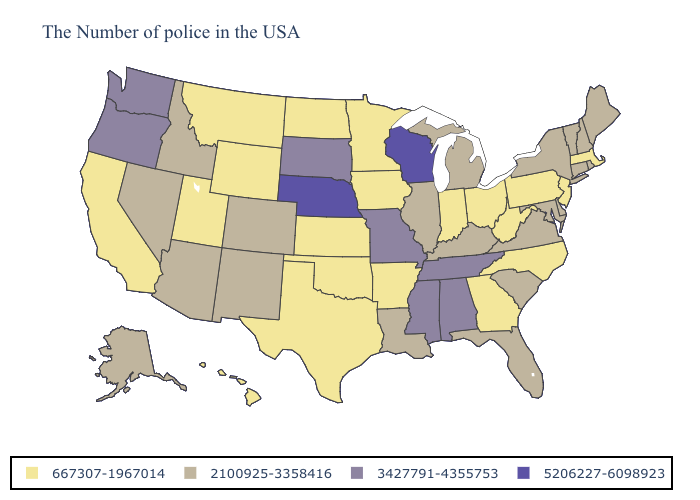Does the first symbol in the legend represent the smallest category?
Write a very short answer. Yes. Does Florida have a lower value than Alabama?
Short answer required. Yes. What is the lowest value in states that border Kentucky?
Keep it brief. 667307-1967014. What is the value of Hawaii?
Be succinct. 667307-1967014. Does Wisconsin have the same value as Nebraska?
Answer briefly. Yes. Name the states that have a value in the range 3427791-4355753?
Quick response, please. Alabama, Tennessee, Mississippi, Missouri, South Dakota, Washington, Oregon. Does Louisiana have a lower value than Nevada?
Keep it brief. No. What is the value of Wisconsin?
Answer briefly. 5206227-6098923. Name the states that have a value in the range 2100925-3358416?
Write a very short answer. Maine, Rhode Island, New Hampshire, Vermont, Connecticut, New York, Delaware, Maryland, Virginia, South Carolina, Florida, Michigan, Kentucky, Illinois, Louisiana, Colorado, New Mexico, Arizona, Idaho, Nevada, Alaska. What is the value of California?
Be succinct. 667307-1967014. What is the lowest value in the West?
Give a very brief answer. 667307-1967014. Does Michigan have a higher value than Vermont?
Quick response, please. No. Which states have the lowest value in the USA?
Answer briefly. Massachusetts, New Jersey, Pennsylvania, North Carolina, West Virginia, Ohio, Georgia, Indiana, Arkansas, Minnesota, Iowa, Kansas, Oklahoma, Texas, North Dakota, Wyoming, Utah, Montana, California, Hawaii. Name the states that have a value in the range 2100925-3358416?
Short answer required. Maine, Rhode Island, New Hampshire, Vermont, Connecticut, New York, Delaware, Maryland, Virginia, South Carolina, Florida, Michigan, Kentucky, Illinois, Louisiana, Colorado, New Mexico, Arizona, Idaho, Nevada, Alaska. Name the states that have a value in the range 667307-1967014?
Keep it brief. Massachusetts, New Jersey, Pennsylvania, North Carolina, West Virginia, Ohio, Georgia, Indiana, Arkansas, Minnesota, Iowa, Kansas, Oklahoma, Texas, North Dakota, Wyoming, Utah, Montana, California, Hawaii. 